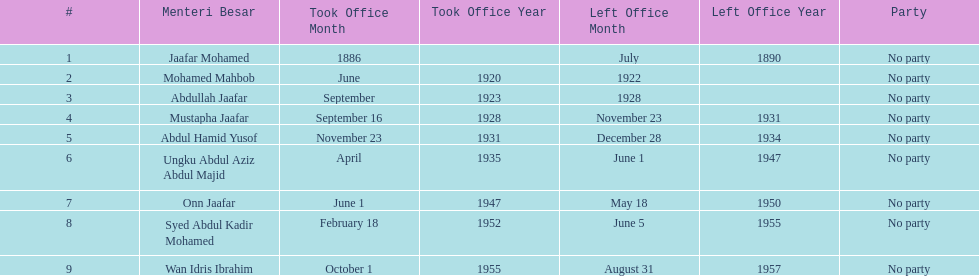What is the number of menteri besars that there have been during the pre-independence period? 9. 